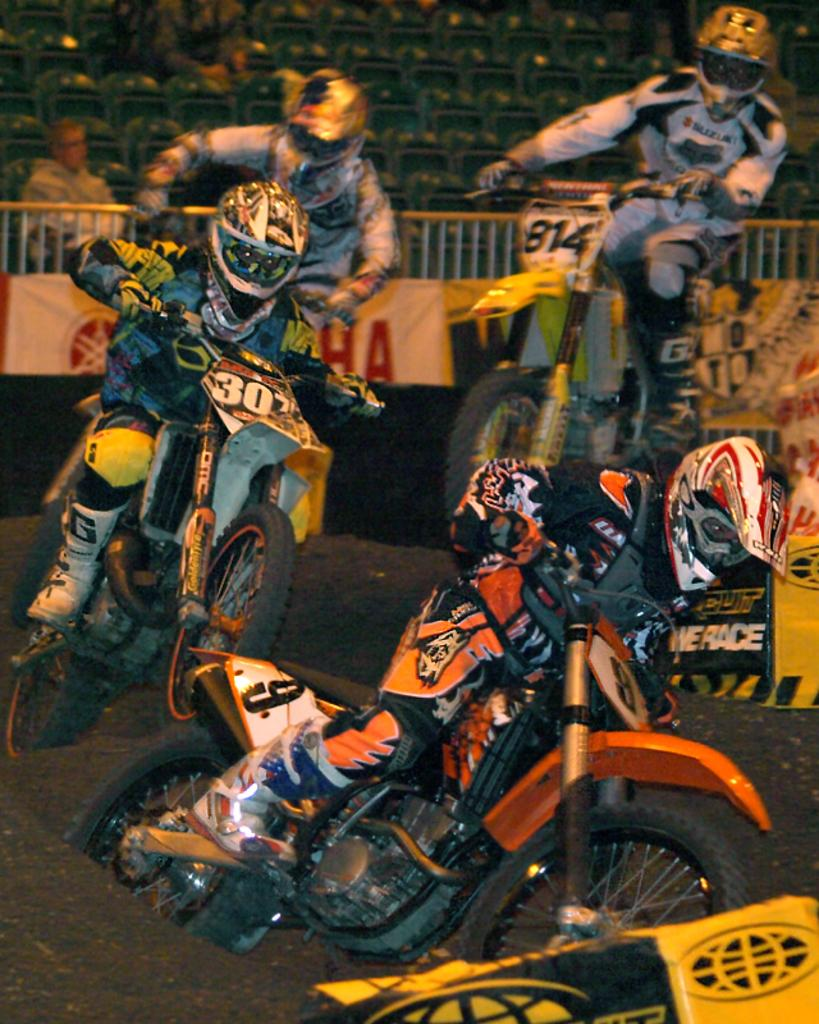What types of subjects can be seen in the image? There are persons and vehicles in the image. What type of terrain is visible in the image? There is sand visible in the image. What other elements are present in the image? There are other objects in the image. What can be seen in the background of the image? In the background of the image, there are banners, railings, other persons, and other objects. How many plastic desks can be seen in the image? There are no plastic desks present in the image. Are there any cats visible in the image? There are no cats present in the image. 